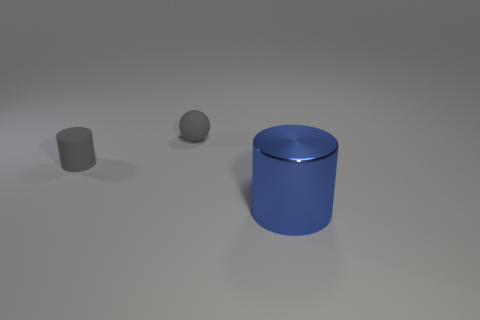Add 3 red rubber cubes. How many objects exist? 6 Subtract all spheres. How many objects are left? 2 Subtract all gray rubber cubes. Subtract all large blue cylinders. How many objects are left? 2 Add 2 shiny cylinders. How many shiny cylinders are left? 3 Add 3 large purple rubber cylinders. How many large purple rubber cylinders exist? 3 Subtract 0 green cylinders. How many objects are left? 3 